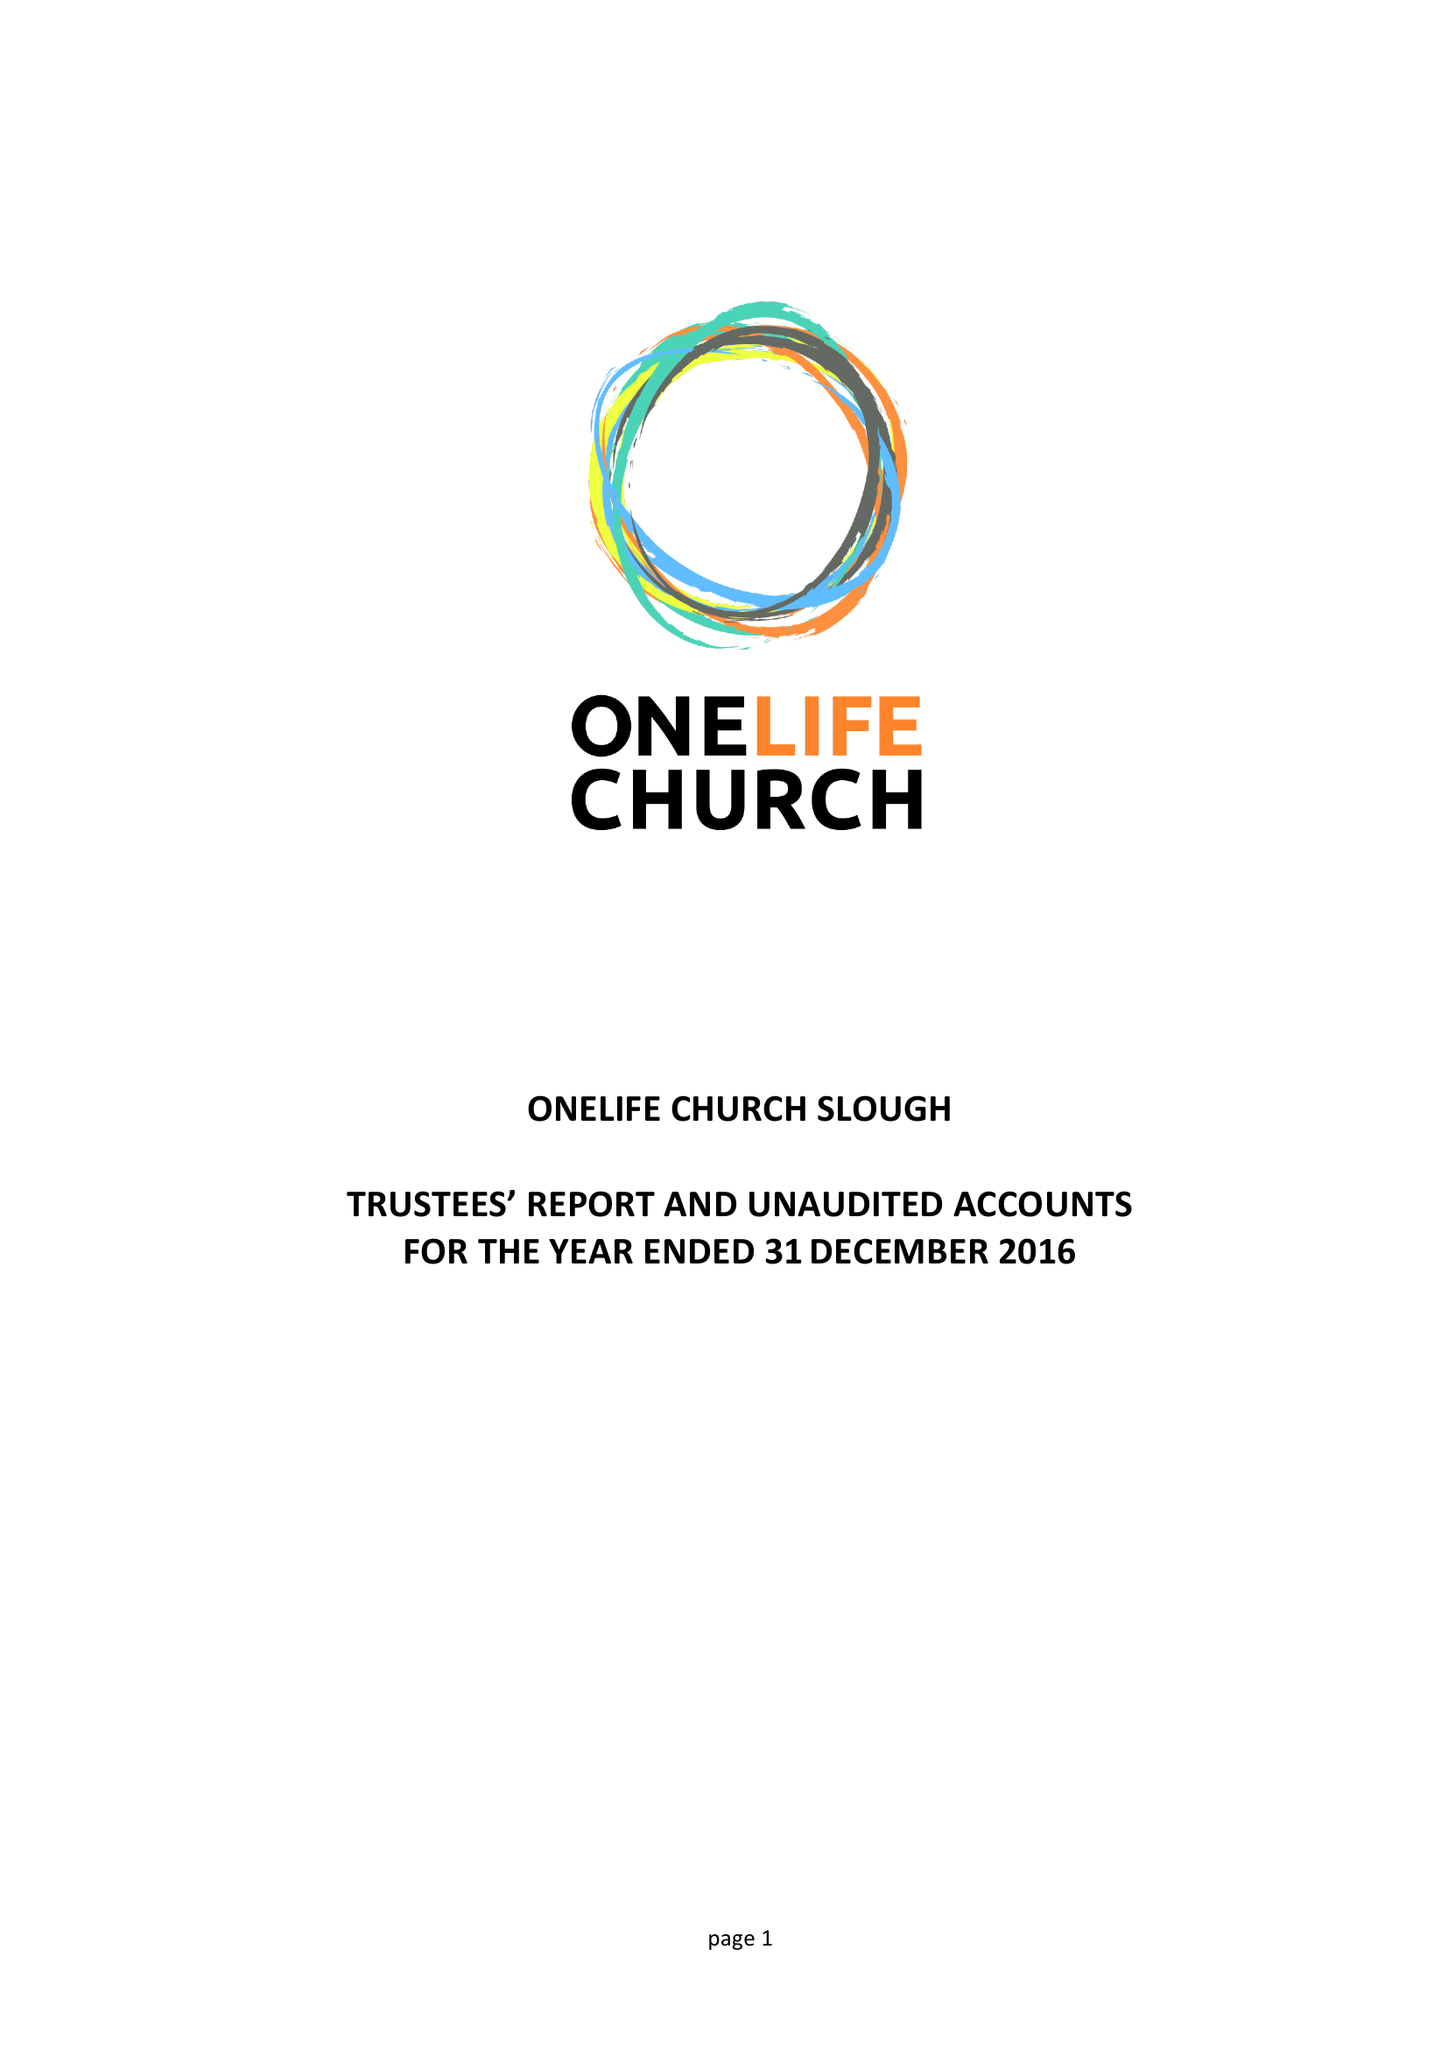What is the value for the spending_annually_in_british_pounds?
Answer the question using a single word or phrase. 27775.00 